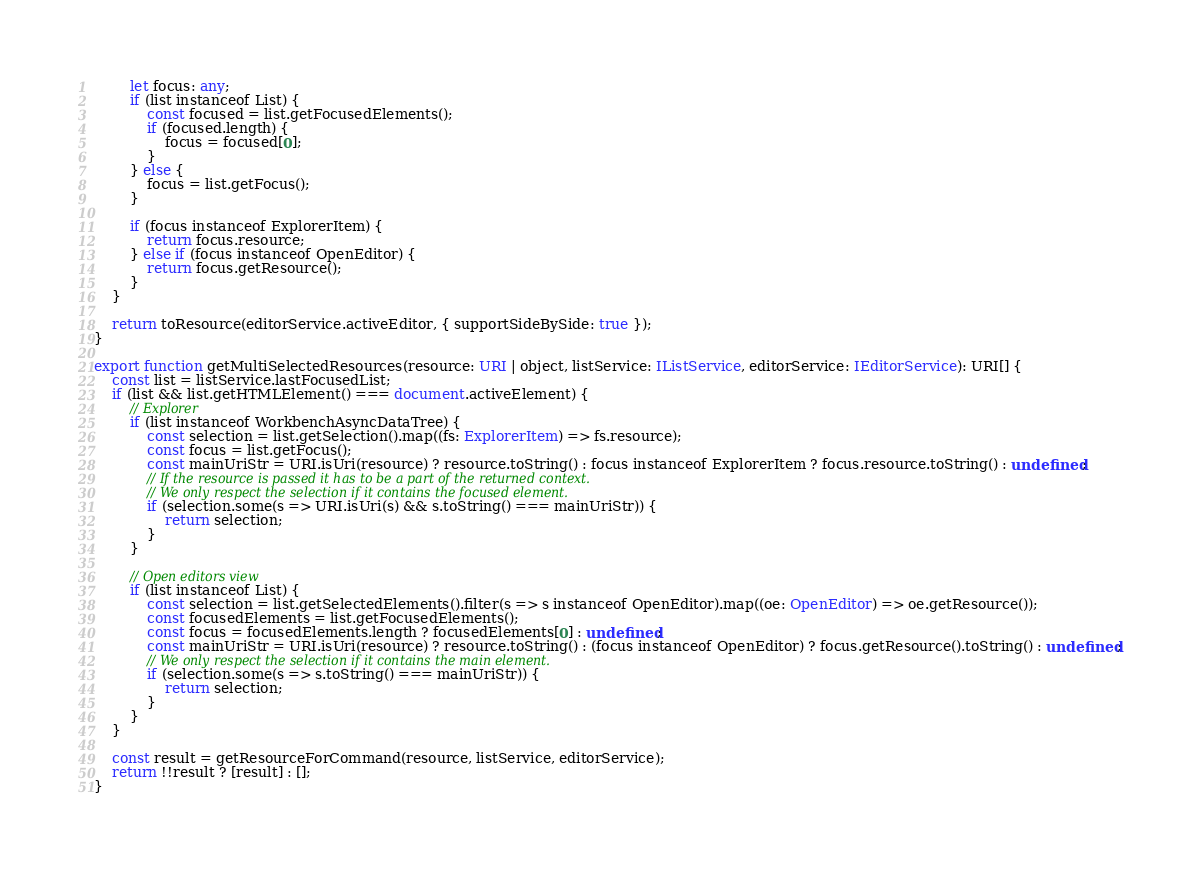<code> <loc_0><loc_0><loc_500><loc_500><_TypeScript_>		let focus: any;
		if (list instanceof List) {
			const focused = list.getFocusedElements();
			if (focused.length) {
				focus = focused[0];
			}
		} else {
			focus = list.getFocus();
		}

		if (focus instanceof ExplorerItem) {
			return focus.resource;
		} else if (focus instanceof OpenEditor) {
			return focus.getResource();
		}
	}

	return toResource(editorService.activeEditor, { supportSideBySide: true });
}

export function getMultiSelectedResources(resource: URI | object, listService: IListService, editorService: IEditorService): URI[] {
	const list = listService.lastFocusedList;
	if (list && list.getHTMLElement() === document.activeElement) {
		// Explorer
		if (list instanceof WorkbenchAsyncDataTree) {
			const selection = list.getSelection().map((fs: ExplorerItem) => fs.resource);
			const focus = list.getFocus();
			const mainUriStr = URI.isUri(resource) ? resource.toString() : focus instanceof ExplorerItem ? focus.resource.toString() : undefined;
			// If the resource is passed it has to be a part of the returned context.
			// We only respect the selection if it contains the focused element.
			if (selection.some(s => URI.isUri(s) && s.toString() === mainUriStr)) {
				return selection;
			}
		}

		// Open editors view
		if (list instanceof List) {
			const selection = list.getSelectedElements().filter(s => s instanceof OpenEditor).map((oe: OpenEditor) => oe.getResource());
			const focusedElements = list.getFocusedElements();
			const focus = focusedElements.length ? focusedElements[0] : undefined;
			const mainUriStr = URI.isUri(resource) ? resource.toString() : (focus instanceof OpenEditor) ? focus.getResource().toString() : undefined;
			// We only respect the selection if it contains the main element.
			if (selection.some(s => s.toString() === mainUriStr)) {
				return selection;
			}
		}
	}

	const result = getResourceForCommand(resource, listService, editorService);
	return !!result ? [result] : [];
}
</code> 